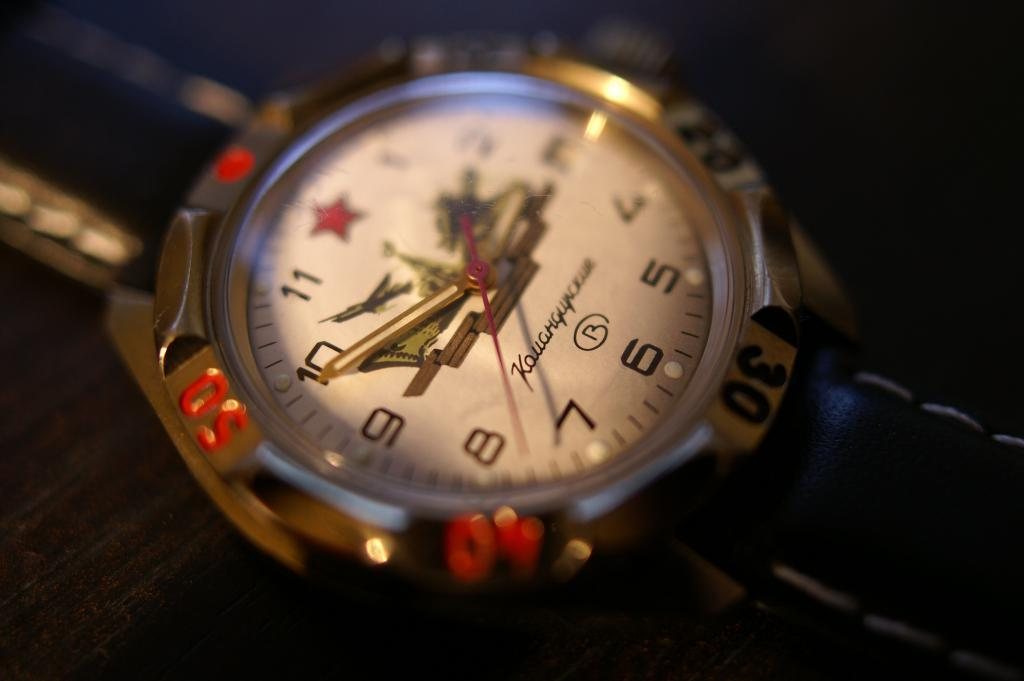<image>
Present a compact description of the photo's key features. A watch with a brand name that starts with K has a red star instead of the number 12 on it. 